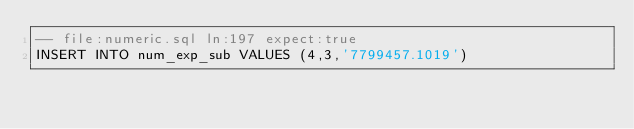<code> <loc_0><loc_0><loc_500><loc_500><_SQL_>-- file:numeric.sql ln:197 expect:true
INSERT INTO num_exp_sub VALUES (4,3,'7799457.1019')
</code> 